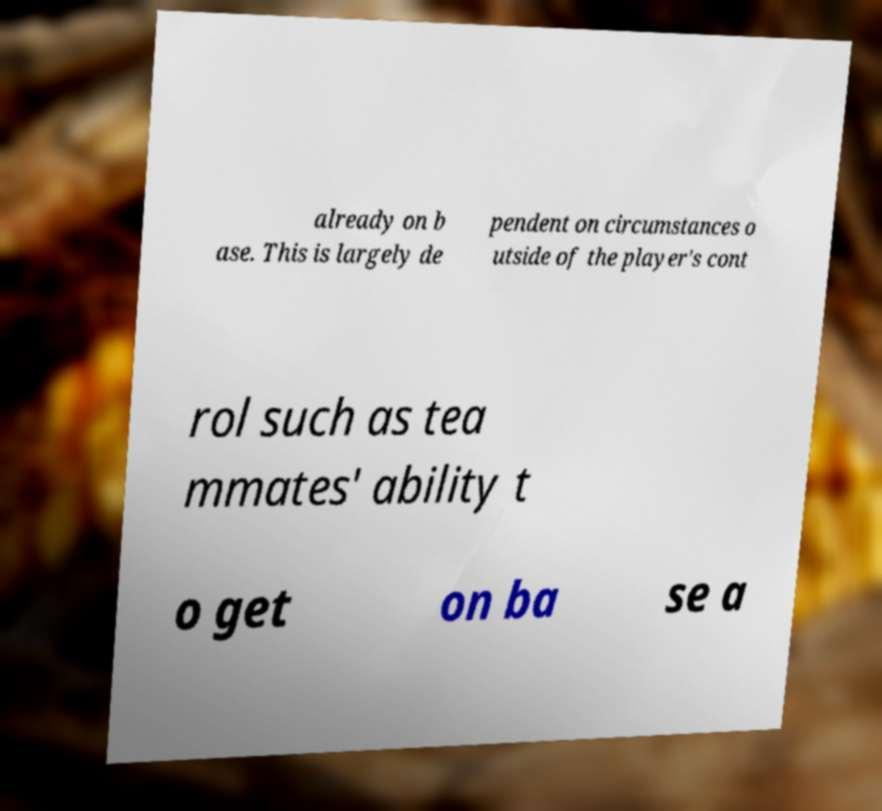There's text embedded in this image that I need extracted. Can you transcribe it verbatim? already on b ase. This is largely de pendent on circumstances o utside of the player's cont rol such as tea mmates' ability t o get on ba se a 